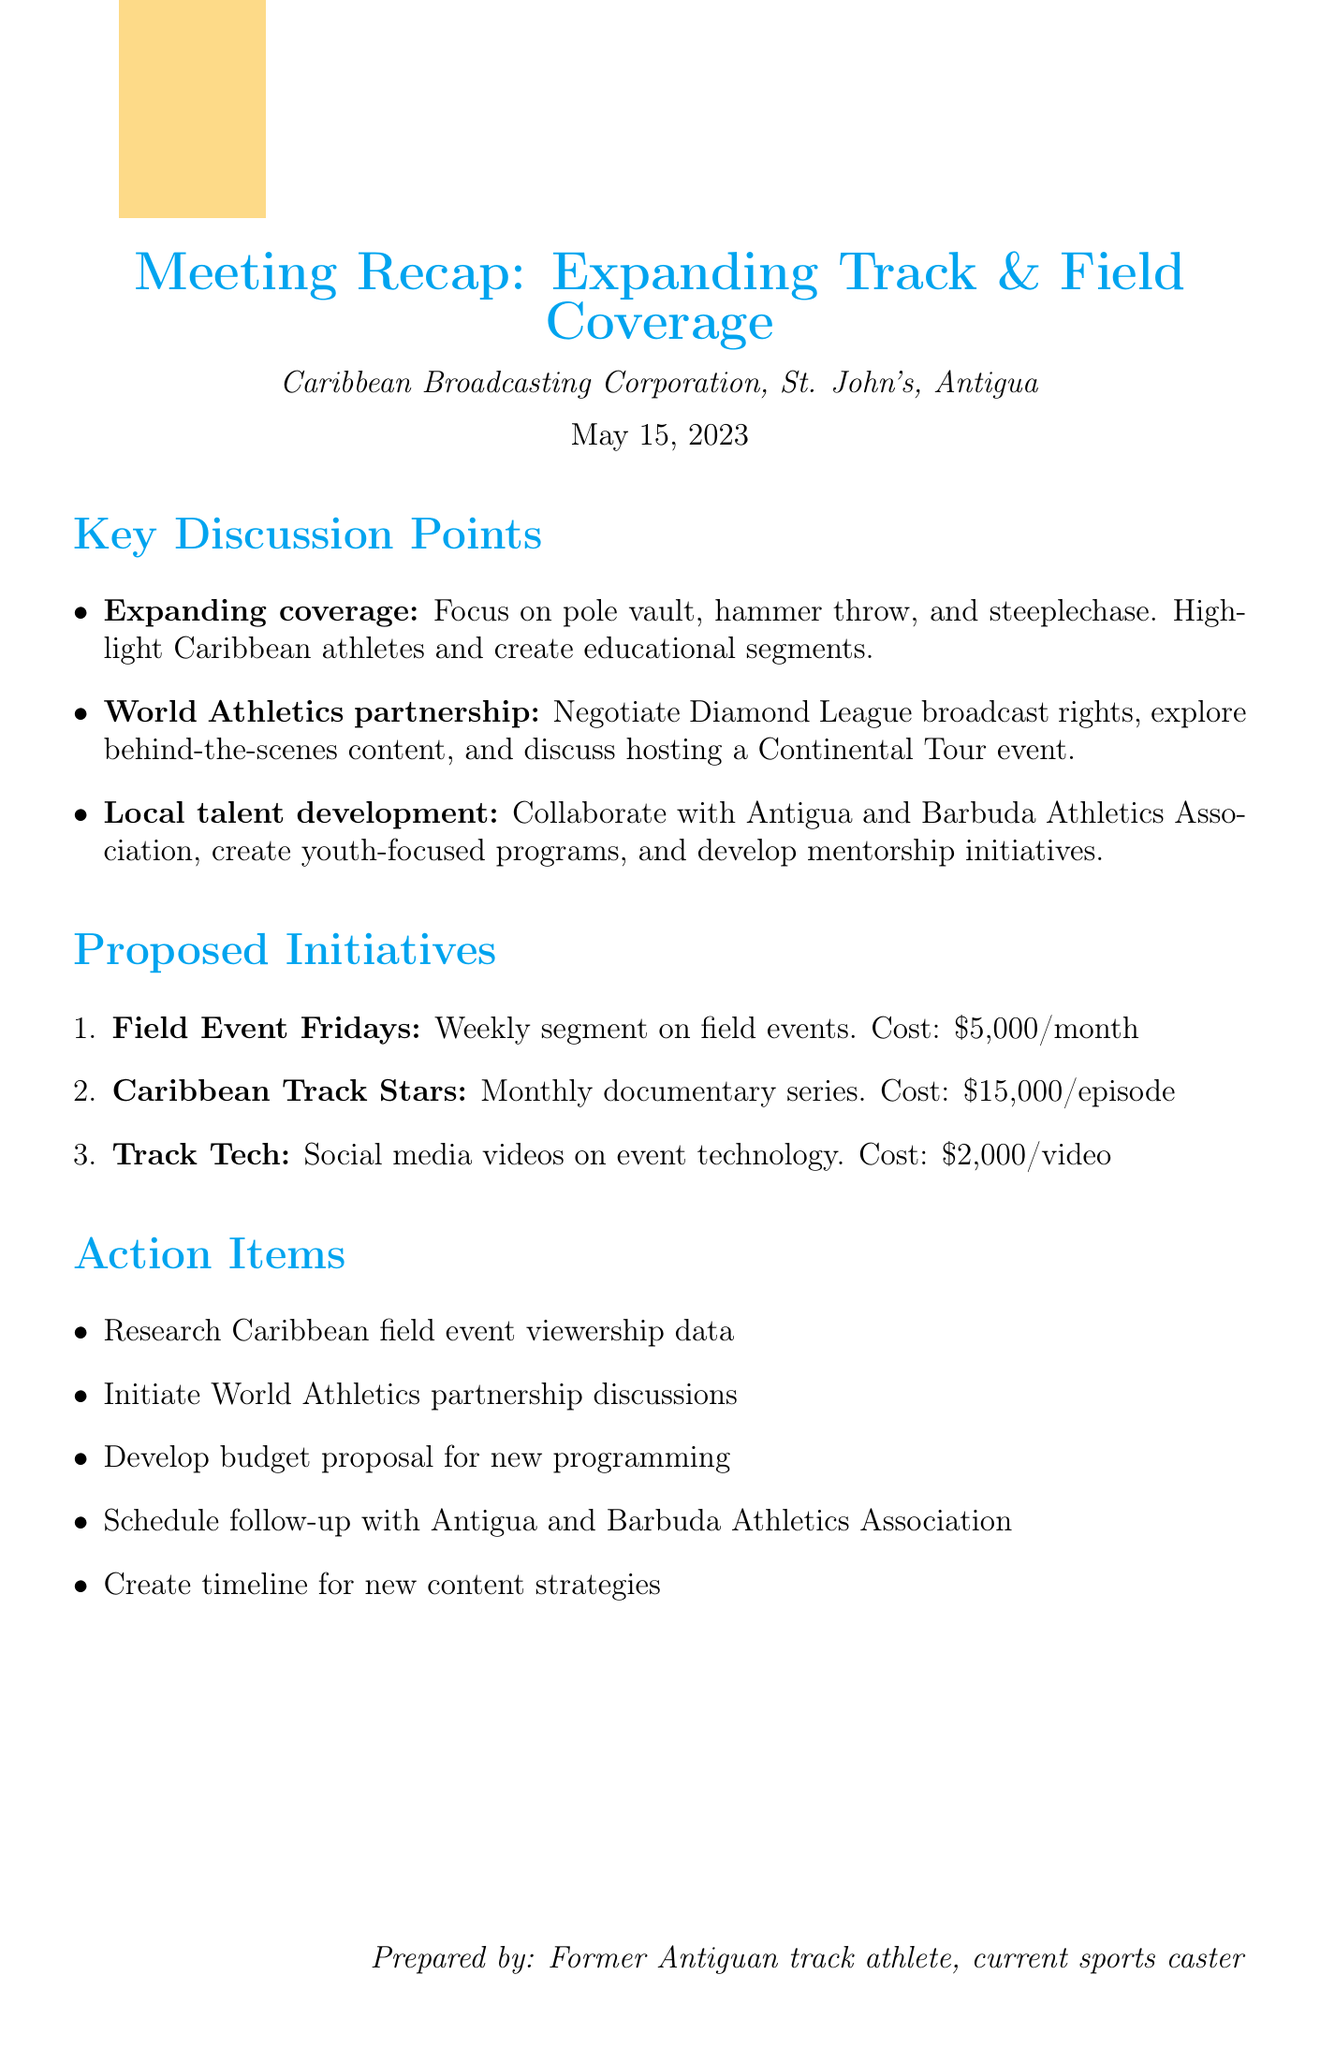What is the date of the meeting? The date of the meeting is specified in the meeting details section of the document.
Answer: May 15, 2023 Where was the meeting held? The location of the meeting is listed in the meeting details section.
Answer: Caribbean Broadcasting Corporation Headquarters, St. John's, Antigua Who is the CEO of the Caribbean Broadcasting Corporation? The name of the CEO is mentioned in the attendees section of the document.
Answer: John Smith What is one of the key points discussed about local talent development? This information can be found in the main discussion points related to local talent development.
Answer: Collaborate with Antigua and Barbuda Athletics Association How much is the projected cost for Field Event Fridays? The projected cost for this initiative is provided in the proposed initiatives section.
Answer: $5,000 per month Which proposed initiative targets younger viewers? The target audience for this initiative is mentioned in its description.
Answer: Track Tech How many action items are listed in the document? The action items are enumerated in a list format.
Answer: Five What does the personal notes section include? This section contains insights related to potential contributions and concerns.
Answer: Potential contributions and concerns What is the focus of the "Caribbean Track Stars" initiative? The focus is described in the initiative's description within the proposed initiatives section.
Answer: Monthly documentary series profiling successful Caribbean athletes in lesser-known disciplines 